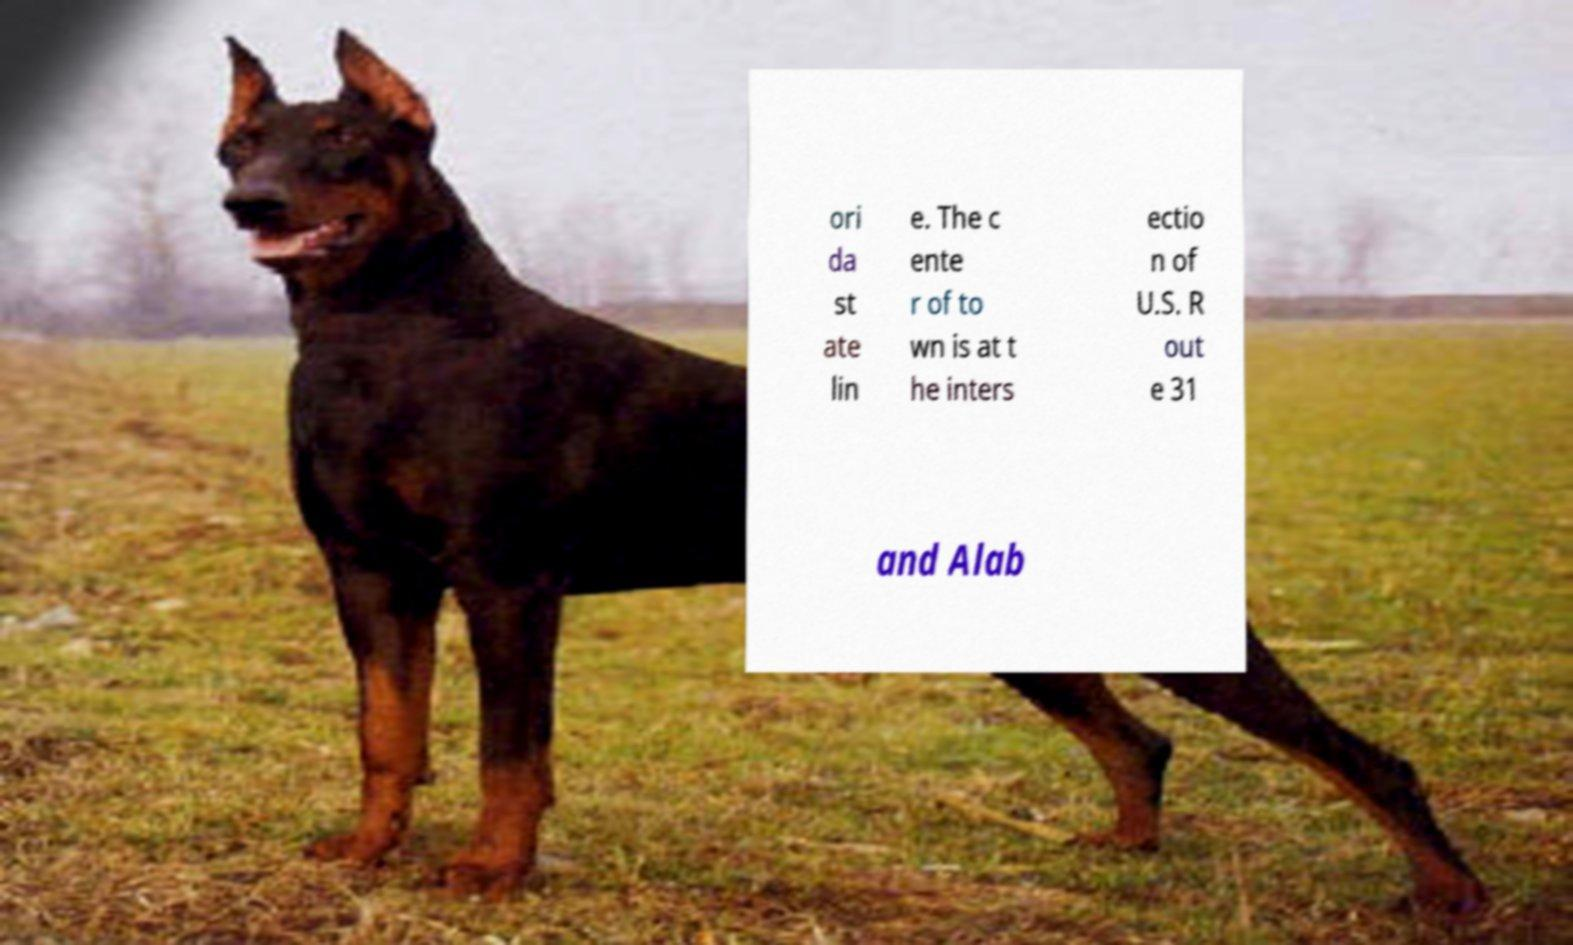What messages or text are displayed in this image? I need them in a readable, typed format. ori da st ate lin e. The c ente r of to wn is at t he inters ectio n of U.S. R out e 31 and Alab 